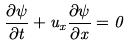<formula> <loc_0><loc_0><loc_500><loc_500>\frac { \partial \psi } { \partial t } + u _ { x } \frac { \partial \psi } { \partial x } = 0</formula> 